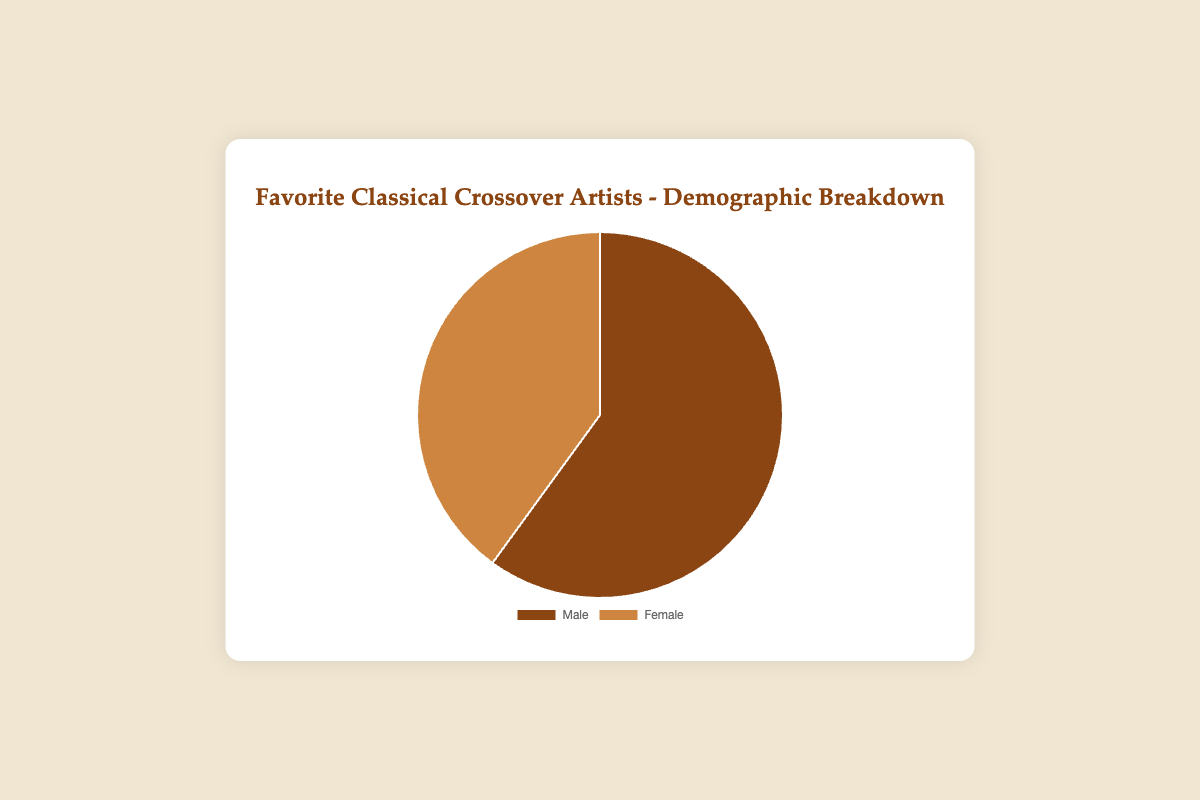What is the percentage of male artists among the favorite classical crossover artists according to the pie chart? The pie chart shows that 60% of the favorite classical crossover artists are male artists.
Answer: 60% What is the percentage of female artists among the favorite classical crossover artists according to the pie chart? The pie chart shows that 40% of the favorite classical crossover artists are female artists.
Answer: 40% Who is more represented among favorite classical crossover artists, male or female artists? By comparing the percentages shown in the pie chart, male artists are more represented (60%) compared to female artists (40%).
Answer: Male artists What percentage points separate male and female favorite classical crossover artists? The pie chart illustrates 60% for male and 40% for female. The difference is calculated as 60% - 40% = 20%.
Answer: 20% If you were to equally distribute the percentages of male and female artists, what would each percentage be? To equalize the distribution, you would combine the 60% for males and 40% for females to get 100%, then divide by 2. So, each would be 100% / 2 = 50%.
Answer: 50% Given the demographical breakdown, is the representation of male artists greater than the representation of female artists by a factor more than 1.5? The ratio of male to female artists is 60% / 40% = 1.5. Since 1.5 is equal to 1.5 and not greater, the factor is not more than 1.5.
Answer: No How does the total percentage of male fans for Andrea Bocelli and Il Divo compare to the total percentage of female fans for Sarah Brightman and Jackie Evancho? Andrea Bocelli has 63% male fans and Il Divo has 65% male fans, giving a total of 63% + 65% = 128%. Sarah Brightman has 45% female fans and Jackie Evancho has 48% female fans, giving a total of 45% + 48% = 93%.
Answer: Male fans (128%) > Female fans (93%) Does the difference in fan percentage between genders for Sarah Brightman (55% male, 45% female) suggest an equal distribution or a significant gender preference? The difference in percentage is 55% - 45% = 10%. A 10% difference suggests some preference but not a highly significant one.
Answer: Preference for males For male artists, which one shows the highest percentage of male fans, and what is that percentage? Among male artists, Il Divo has the highest percentage of male fans at 65%.
Answer: 65% If we calculated the weighted average percentage of male fans for all ten artists, how would this impact our understanding of the favorite gender demographics presented in the pie chart? To calculate the weighted average, consider each percentage and the count of artists: Sum(63+55+58+52+50+53+51+57)/10 = 54.9%. Comparing this to the pie chart's 60%, it shows that while specific artists exhibit various levels of fan percentages, the overall favorite describes a rounding difference.
Answer: Slight discrepancy 